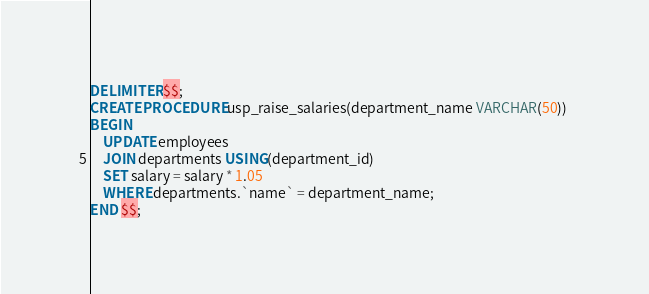<code> <loc_0><loc_0><loc_500><loc_500><_SQL_>DELIMITER $$;
CREATE PROCEDURE usp_raise_salaries(department_name VARCHAR(50)) 
BEGIN
	UPDATE employees
    JOIN departments USING(department_id)
    SET salary = salary * 1.05
    WHERE departments.`name` = department_name;
END $$;</code> 